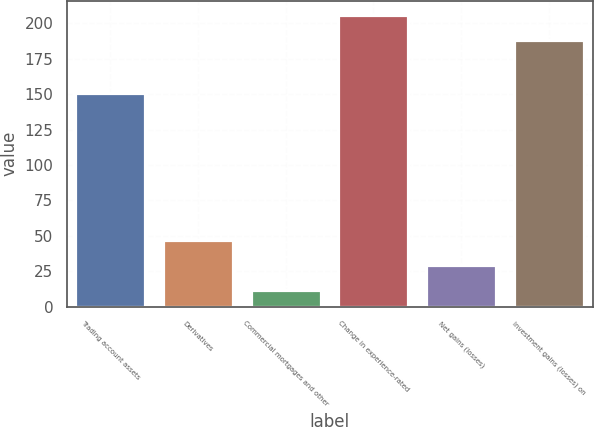Convert chart to OTSL. <chart><loc_0><loc_0><loc_500><loc_500><bar_chart><fcel>Trading account assets<fcel>Derivatives<fcel>Commercial mortgages and other<fcel>Change in experience-rated<fcel>Net gains (losses)<fcel>Investment gains (losses) on<nl><fcel>151<fcel>47.2<fcel>12<fcel>205.6<fcel>29.6<fcel>188<nl></chart> 